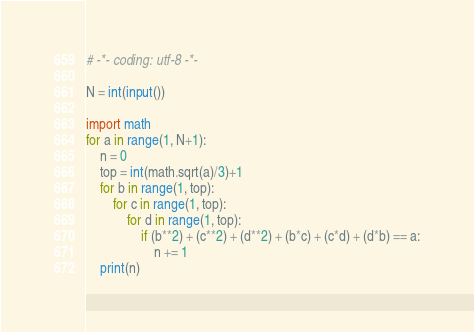Convert code to text. <code><loc_0><loc_0><loc_500><loc_500><_Python_># -*- coding: utf-8 -*-

N = int(input())

import math
for a in range(1, N+1):
    n = 0
    top = int(math.sqrt(a)/3)+1
    for b in range(1, top):
        for c in range(1, top):
            for d in range(1, top):
                if (b**2) + (c**2) + (d**2) + (b*c) + (c*d) + (d*b) == a:
                    n += 1
    print(n)</code> 